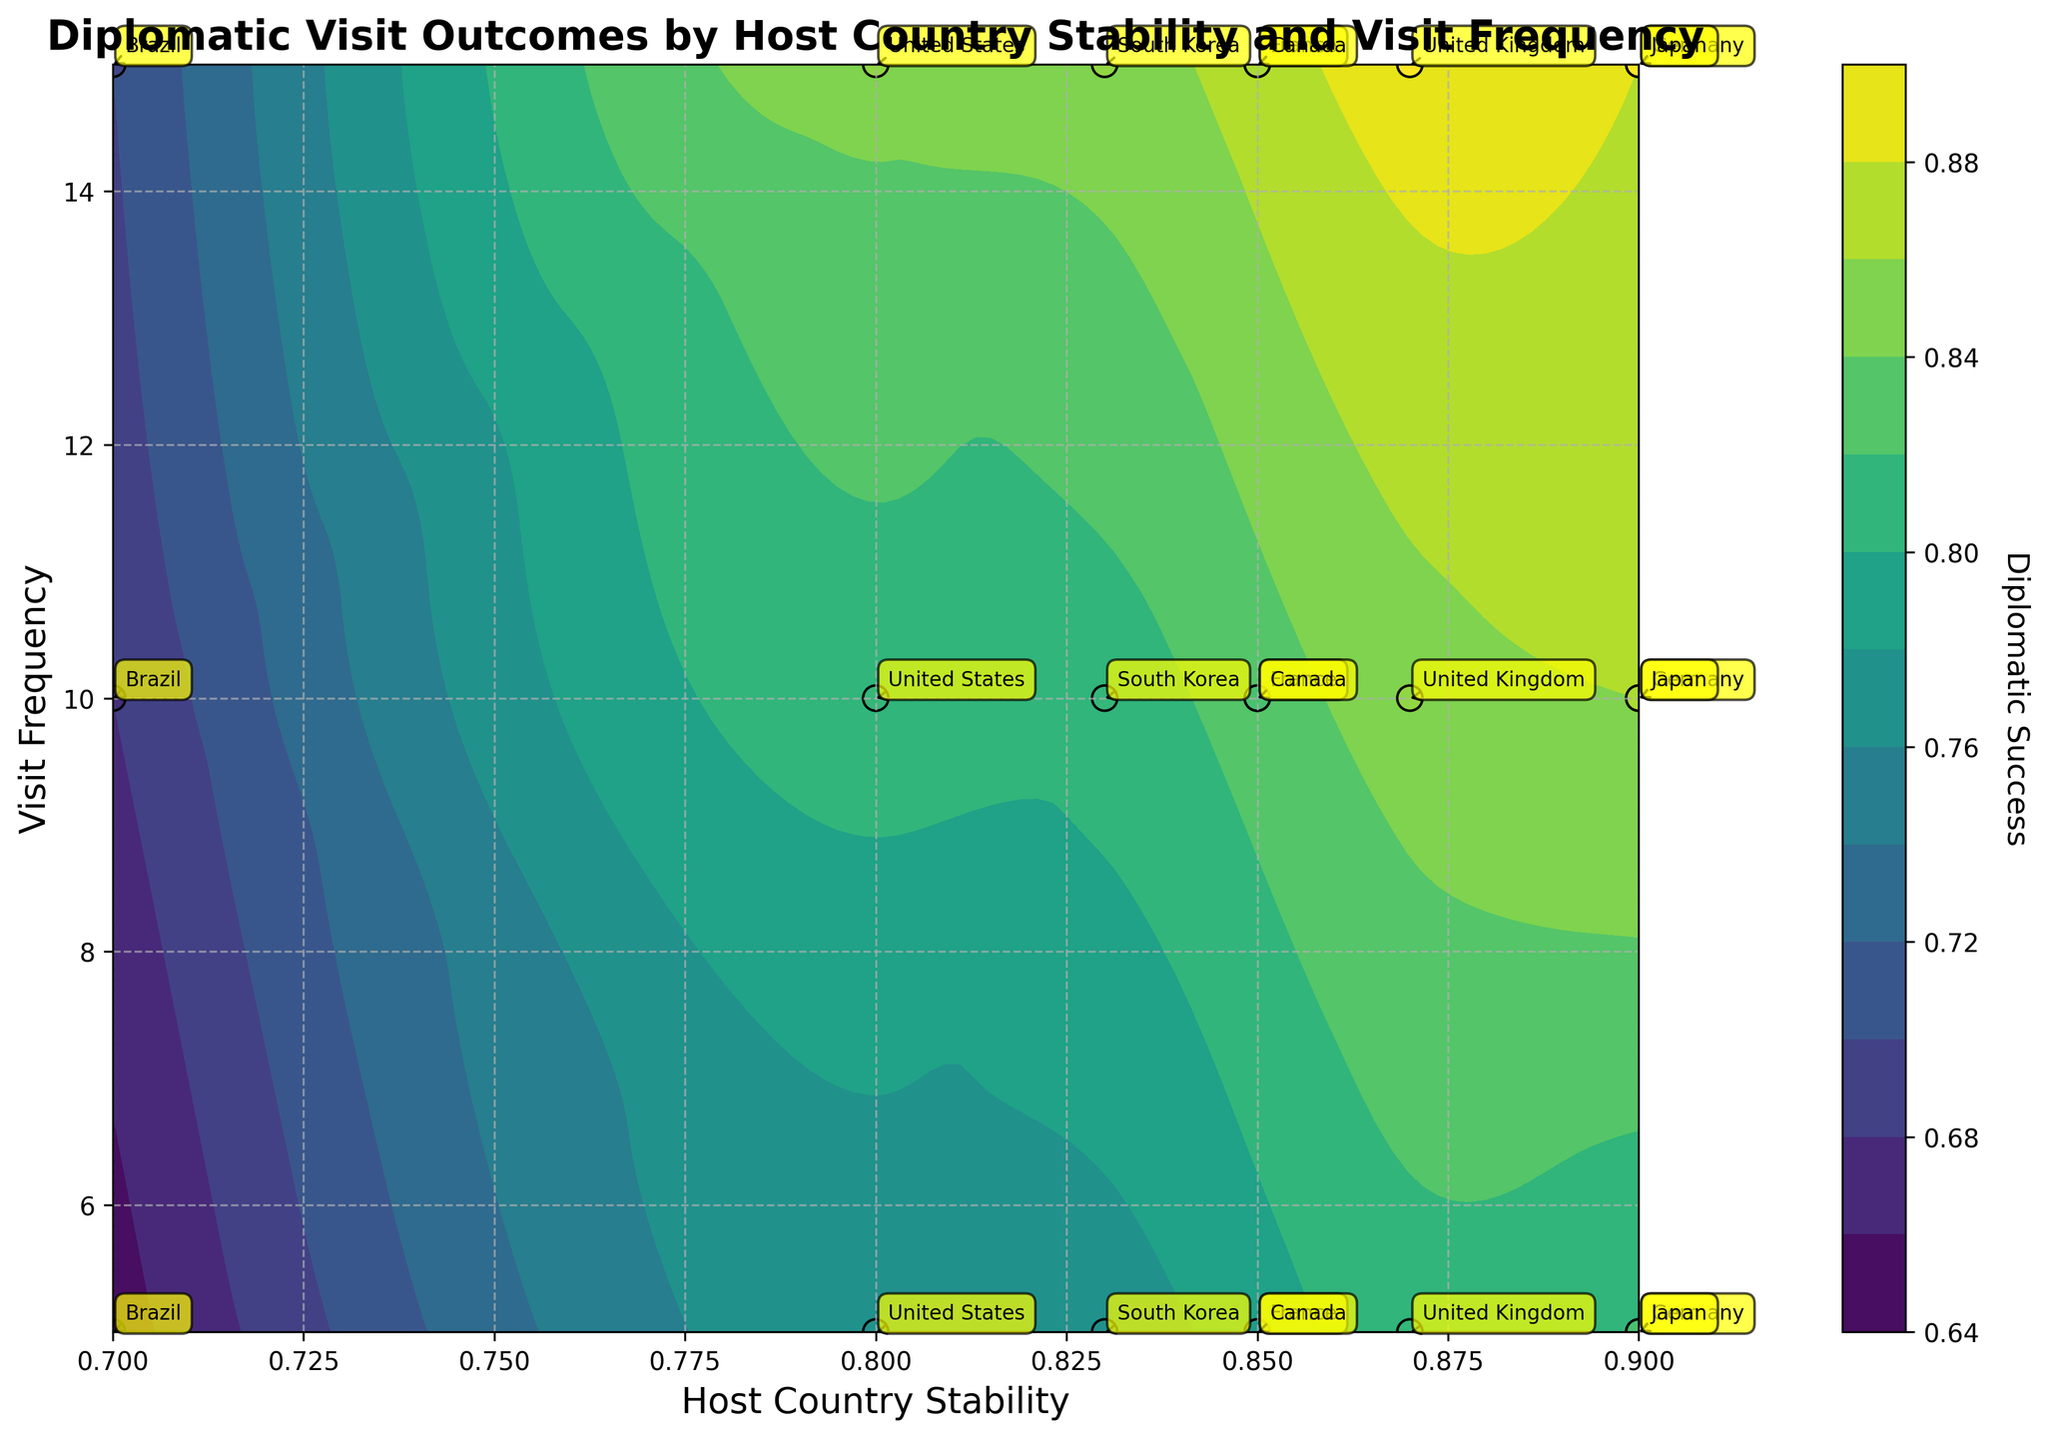What is the title of the plot? The title is usually located at the top center of the plot. Here, it clearly states: "Diplomatic Visit Outcomes by Host Country Stability and Visit Frequency"
Answer: Diplomatic Visit Outcomes by Host Country Stability and Visit Frequency What does the colorbar represent? The colorbar on the right side of the plot shows the range of values it represents. It has the label "Diplomatic Success." Thus, the color gradient indicates varying levels of Diplomatic Success.
Answer: Diplomatic Success How many unique countries are annotated in the plot? Each country is labeled directly on the plot. By counting all unique labels, we find: United States, Germany, France, United Kingdom, Brazil, Japan, Canada, South Korea.
Answer: 8 Which country has the highest Diplomatic Success at a Host Country Stability of 0.87 and a Visit Frequency of 15? The plot shows data points and labels for each country. For Host Country Stability of 0.87 and a Visit Frequency of 15, the country label is "United Kingdom" and its Diplomatic Success is at the highest end of its dataset.
Answer: United Kingdom Compare the Diplomatic Success for the United States and Brazil at a Visit Frequency of 10. Which country has a higher success rate? By looking at the plot, locate the points for the United States and Brazil at a Visit Frequency of 10. The plot shows the United States at approximately 0.81 and Brazil at around 0.68. Clearly, the United States has a higher Diplomatic Success compared to Brazil.
Answer: United States What is the general trend of Diplomatic Success as Host Country Stability increases from 0.7 to 0.9, assuming a constant Visit Frequency of 10? By analyzing the contour lines corresponding to a Visit Frequency of 10 across different levels of Host Country Stability, we notice that Diplomatic Success increases as stability increases. This trend is indicated by the color gradient transitioning to higher values.
Answer: Increases For which country does an increase in Visit Frequency from 5 to 15 produce the largest gain in Diplomatic Success? By comparing the annotated data points for each country at Visit Frequencies 5, 10, and 15, and observing the gradient of the contour, the largest increase appears for Brazil, which goes from about 0.65 to about 0.70, a 0.05 increase.
Answer: Brazil Which color on the contour plot corresponds to the highest Diplomatic Success values? Observing the color gradient on the contour plot, the highest Diplomatic Success is at the lightest colors (yellowish). The colorbar confirms this transition from darker to lighter colors as values increase.
Answer: Yellowish Is there a country that shows a Diplomatic Success greater than 0.85 for any data point on the plot? Referring to the individual data points and annotations, Germany, France, United Kingdom, and Japan have some points exceeding 0.85 in Diplomatic Success, especially at higher Visit Frequencies.
Answer: Yes What is the range of Host Country Stability values covered in the plot? The x-axis represents Host Country Stability, and the range is evident from the plot boundaries. It spans from around 0.7 to 0.9.
Answer: 0.7 to 0.9 